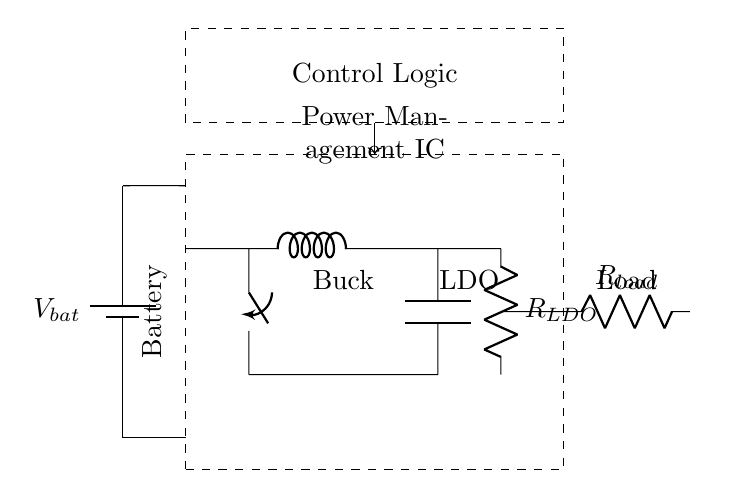What is the main function of the Power Management IC? The main function of the Power Management IC is to regulate the voltage and current supplied to the smartphone's components, ensuring efficient power usage.
Answer: regulate voltage and current What type of regulator is used in this circuit? The circuit uses a Low Dropout Regulator (LDO), which allows for regulating output voltage with a small difference between input and output voltage.
Answer: Low Dropout Regulator Which component indicates the load in this circuit? The load in the circuit is represented by the resistor labeled R_load, which consumes power from the circuit.
Answer: R_load What is the purpose of the Buck Converter in this diagram? The Buck Converter steps down voltage from the battery for efficient energy delivery to the load while minimizing power loss.
Answer: step down voltage How many resistors are present in this circuit? There are two resistors in the circuit, one labeled as R_LDO (Low Dropout Regulator) and the other as R_load (Load).
Answer: two What are the main characteristics of the battery shown? The battery is indicated by the component labeled V_bat, which serves as the primary energy source in the circuit.
Answer: energy source 